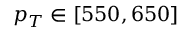Convert formula to latex. <formula><loc_0><loc_0><loc_500><loc_500>p _ { T } \in [ 5 5 0 , 6 5 0 ]</formula> 